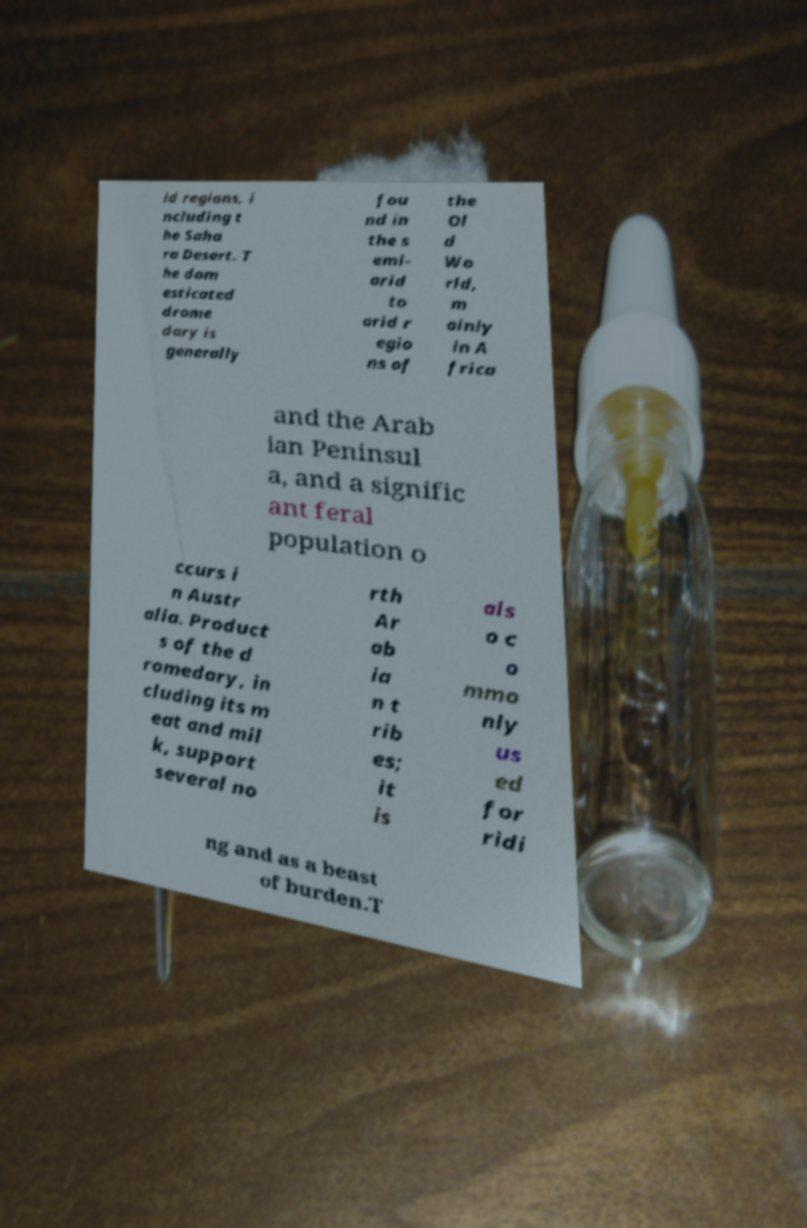Can you read and provide the text displayed in the image?This photo seems to have some interesting text. Can you extract and type it out for me? id regions, i ncluding t he Saha ra Desert. T he dom esticated drome dary is generally fou nd in the s emi- arid to arid r egio ns of the Ol d Wo rld, m ainly in A frica and the Arab ian Peninsul a, and a signific ant feral population o ccurs i n Austr alia. Product s of the d romedary, in cluding its m eat and mil k, support several no rth Ar ab ia n t rib es; it is als o c o mmo nly us ed for ridi ng and as a beast of burden.T 